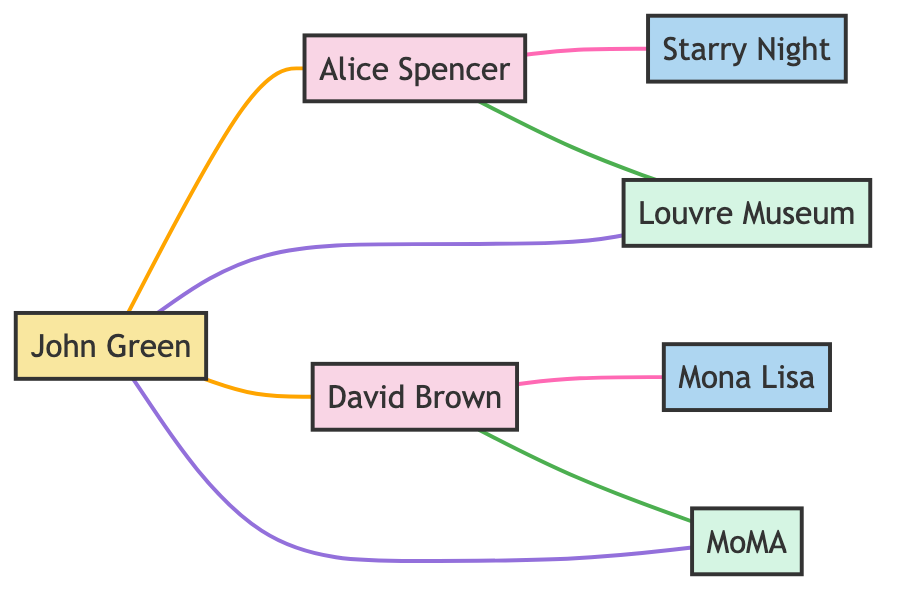What are the names of the collectors in the diagram? The diagram lists two collectors: Alice Spencer and David Brown, identifiable by the node labels corresponding to "Collector1" and "Collector2."
Answer: Alice Spencer, David Brown How many art pieces are shown in the diagram? The diagram contains two art pieces: "Starry Night by Vincent van Gogh" and "Mona Lisa by Leonardo da Vinci," which are listed as "ArtPiece1" and "ArtPiece2."
Answer: 2 What relationship does Alice Spencer have with the Louvre Museum? The relationship indicated in the diagram is "frequent visitor," as shown by the edge connecting Collector1 (Alice Spencer) and Gallery1 (Louvre Museum).
Answer: frequent visitor How many galleries are connected to the collectors in the diagram? There are two galleries indicated: the Louvre Museum and the Museum of Modern Art. Both are connections to their respective collectors, counted through the edges linked to Gallery1 and Gallery2.
Answer: 2 Which advisor is connected to both collectors? The diagram shows that John Green, indicated as "Advisor," is connected to both Alice Spencer and David Brown through advisory relationships.
Answer: John Green Which art piece does David Brown own? The diagram specifies that David Brown owns the "Mona Lisa by Leonardo da Vinci," represented as the edge between Collector2 and ArtPiece2.
Answer: Mona Lisa by Leonardo da Vinci What type of relationship does John Green have with the galleries? John Green has a "collaborates with" relationship with both galleries, as indicated by the connecting edges to Gallery1 and Gallery2.
Answer: collaborates with Are the collectors directly connected to any art pieces? Yes, the diagram shows each collector directly connected to their respective art piece through ownership relationships: Alice Spencer with "Starry Night" and David Brown with "Mona Lisa."
Answer: Yes 